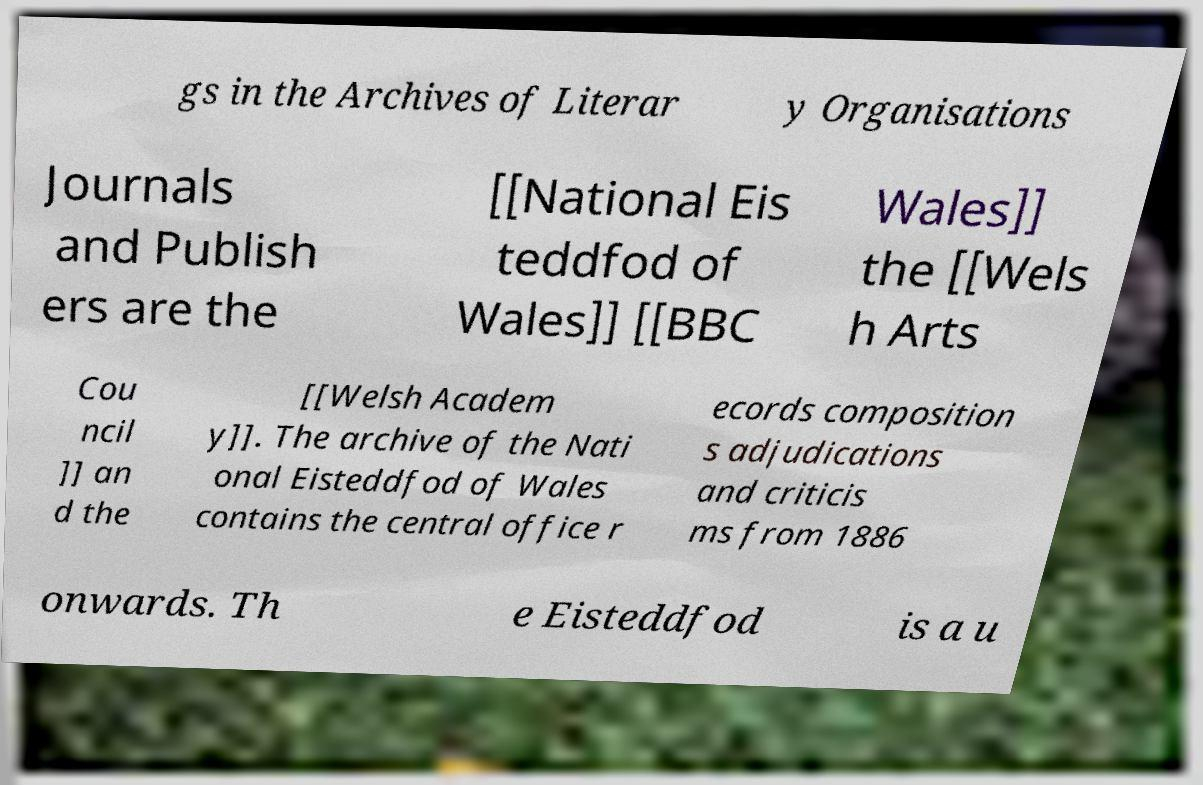Could you assist in decoding the text presented in this image and type it out clearly? gs in the Archives of Literar y Organisations Journals and Publish ers are the [[National Eis teddfod of Wales]] [[BBC Wales]] the [[Wels h Arts Cou ncil ]] an d the [[Welsh Academ y]]. The archive of the Nati onal Eisteddfod of Wales contains the central office r ecords composition s adjudications and criticis ms from 1886 onwards. Th e Eisteddfod is a u 